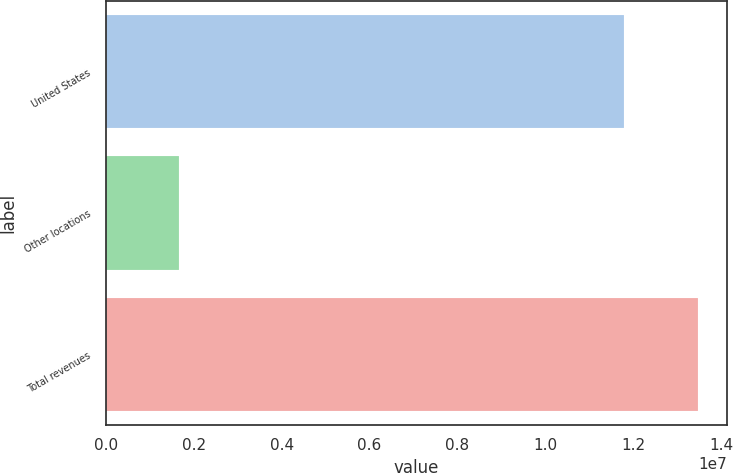Convert chart. <chart><loc_0><loc_0><loc_500><loc_500><bar_chart><fcel>United States<fcel>Other locations<fcel>Total revenues<nl><fcel>1.18001e+07<fcel>1.66993e+06<fcel>1.34701e+07<nl></chart> 